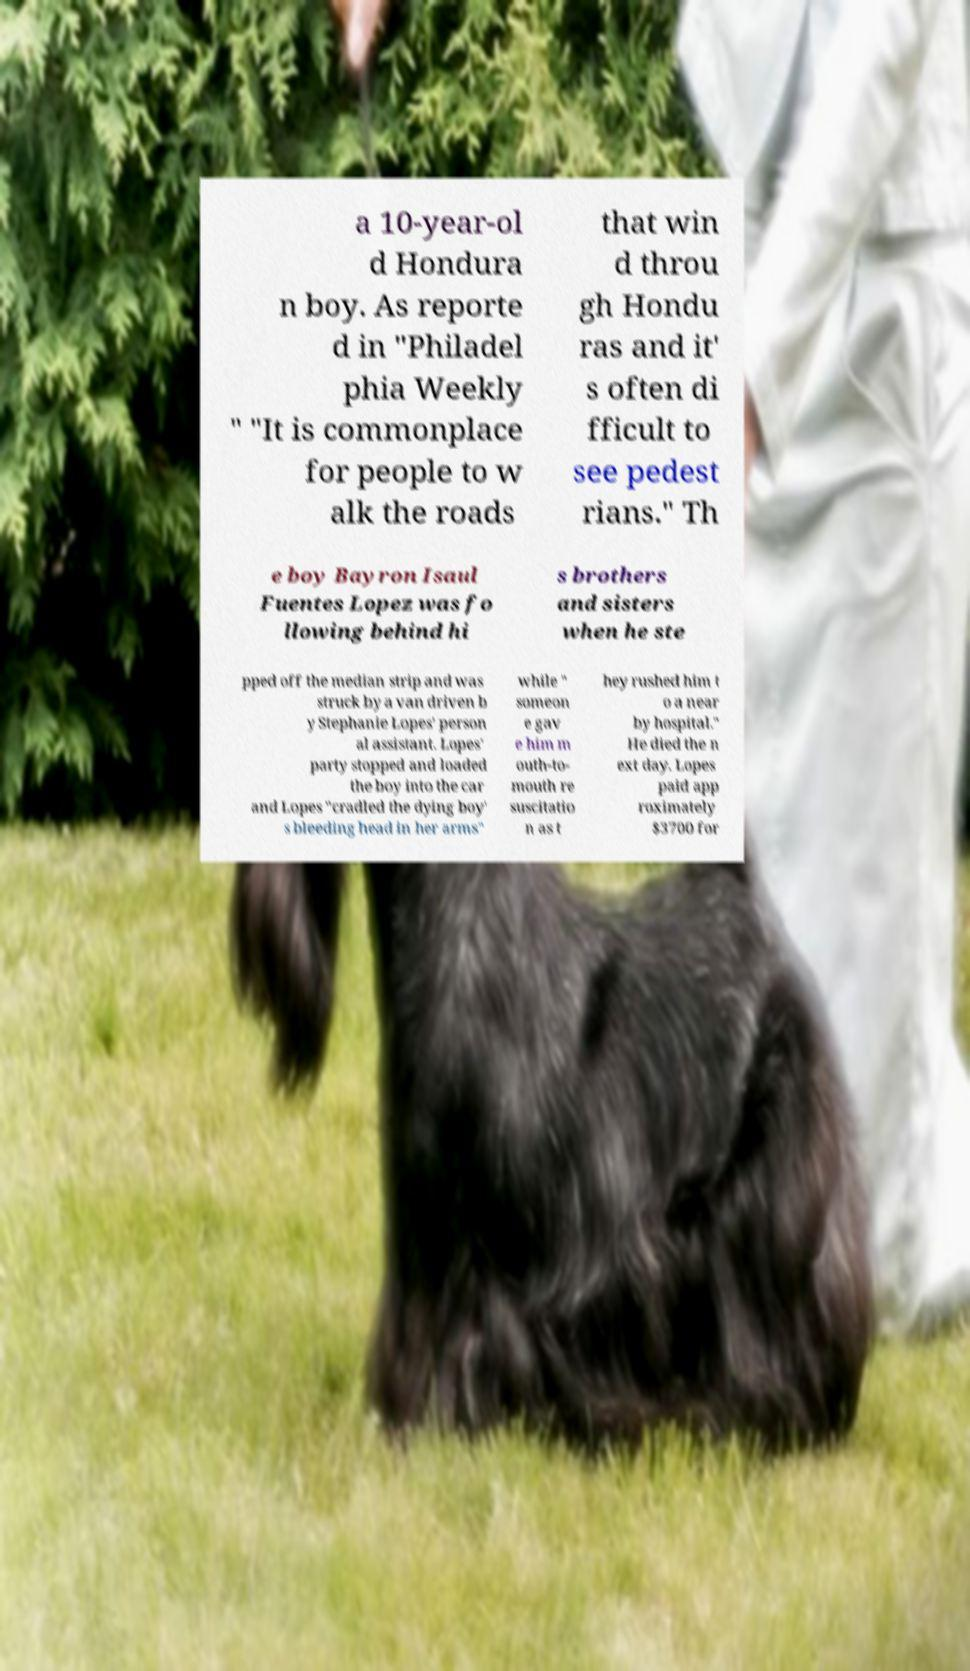I need the written content from this picture converted into text. Can you do that? a 10-year-ol d Hondura n boy. As reporte d in "Philadel phia Weekly " "It is commonplace for people to w alk the roads that win d throu gh Hondu ras and it' s often di fficult to see pedest rians." Th e boy Bayron Isaul Fuentes Lopez was fo llowing behind hi s brothers and sisters when he ste pped off the median strip and was struck by a van driven b y Stephanie Lopes' person al assistant. Lopes' party stopped and loaded the boy into the car and Lopes "cradled the dying boy' s bleeding head in her arms" while " someon e gav e him m outh-to- mouth re suscitatio n as t hey rushed him t o a near by hospital." He died the n ext day. Lopes paid app roximately $3700 for 